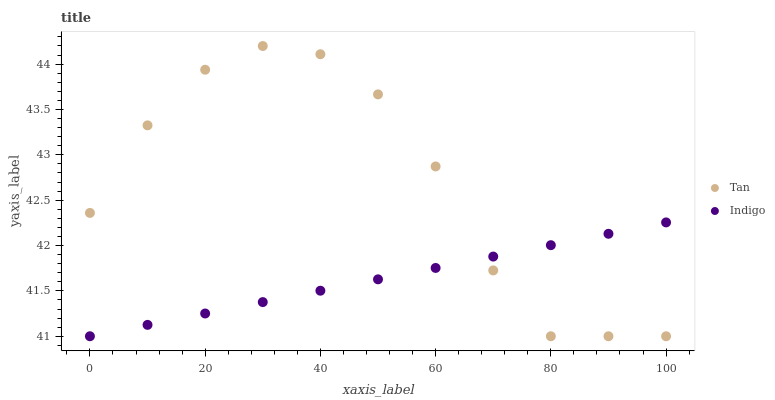Does Indigo have the minimum area under the curve?
Answer yes or no. Yes. Does Tan have the maximum area under the curve?
Answer yes or no. Yes. Does Indigo have the maximum area under the curve?
Answer yes or no. No. Is Indigo the smoothest?
Answer yes or no. Yes. Is Tan the roughest?
Answer yes or no. Yes. Is Indigo the roughest?
Answer yes or no. No. Does Tan have the lowest value?
Answer yes or no. Yes. Does Tan have the highest value?
Answer yes or no. Yes. Does Indigo have the highest value?
Answer yes or no. No. Does Tan intersect Indigo?
Answer yes or no. Yes. Is Tan less than Indigo?
Answer yes or no. No. Is Tan greater than Indigo?
Answer yes or no. No. 